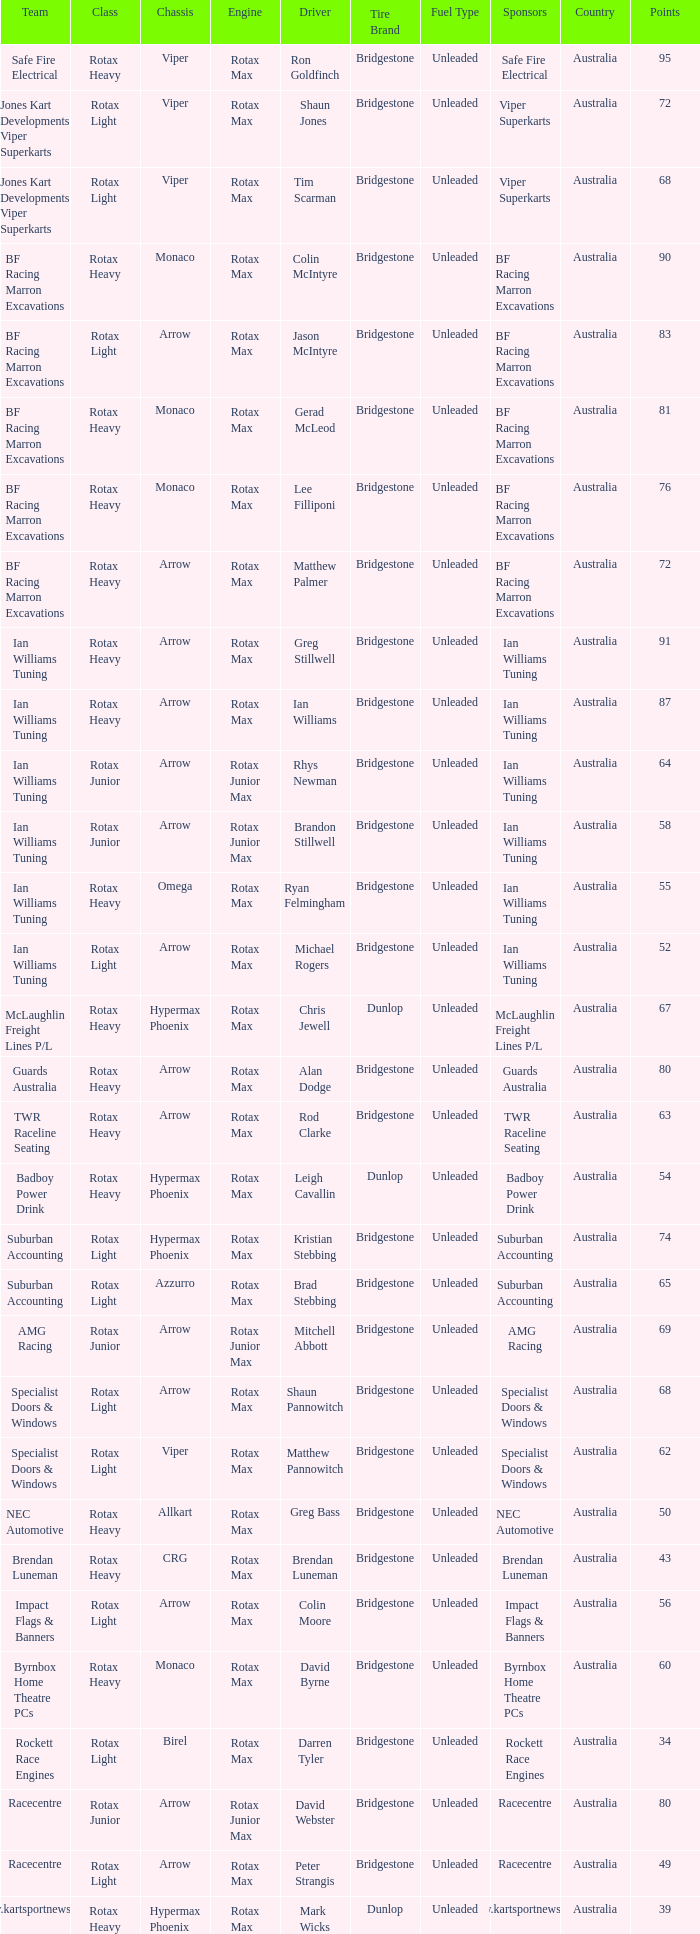What is the name of the driver with a rotax max engine, in the rotax heavy class, with arrow as chassis and on the TWR Raceline Seating team? Rod Clarke. 